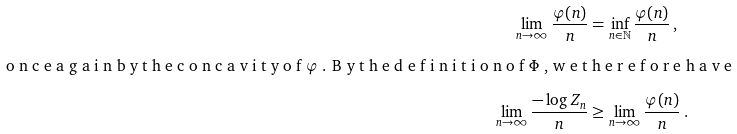<formula> <loc_0><loc_0><loc_500><loc_500>\lim _ { n \to \infty } \frac { \varphi ( n ) } { n } & = \inf _ { n \in \mathbb { N } } \frac { \varphi ( n ) } { n } \, , \intertext { o n c e a g a i n b y t h e c o n c a v i t y o f $ \varphi $ . B y t h e d e f i n i t i o n o f $ \Phi $ , w e t h e r e f o r e h a v e } \lim _ { n \to \infty } \frac { - \log Z _ { n } } { n } & \geq \lim _ { n \to \infty } \frac { \varphi ( n ) } { n } \, .</formula> 